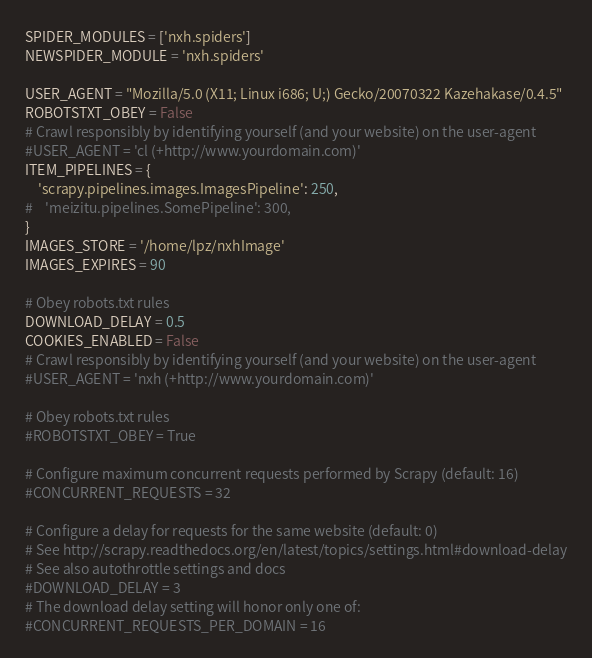Convert code to text. <code><loc_0><loc_0><loc_500><loc_500><_Python_>SPIDER_MODULES = ['nxh.spiders']
NEWSPIDER_MODULE = 'nxh.spiders'

USER_AGENT = "Mozilla/5.0 (X11; Linux i686; U;) Gecko/20070322 Kazehakase/0.4.5"
ROBOTSTXT_OBEY = False
# Crawl responsibly by identifying yourself (and your website) on the user-agent
#USER_AGENT = 'cl (+http://www.yourdomain.com)'
ITEM_PIPELINES = {
	'scrapy.pipelines.images.ImagesPipeline': 250,
#    'meizitu.pipelines.SomePipeline': 300,
}
IMAGES_STORE = '/home/lpz/nxhImage'
IMAGES_EXPIRES = 90

# Obey robots.txt rules
DOWNLOAD_DELAY = 0.5
COOKIES_ENABLED = False
# Crawl responsibly by identifying yourself (and your website) on the user-agent
#USER_AGENT = 'nxh (+http://www.yourdomain.com)'

# Obey robots.txt rules
#ROBOTSTXT_OBEY = True

# Configure maximum concurrent requests performed by Scrapy (default: 16)
#CONCURRENT_REQUESTS = 32

# Configure a delay for requests for the same website (default: 0)
# See http://scrapy.readthedocs.org/en/latest/topics/settings.html#download-delay
# See also autothrottle settings and docs
#DOWNLOAD_DELAY = 3
# The download delay setting will honor only one of:
#CONCURRENT_REQUESTS_PER_DOMAIN = 16</code> 